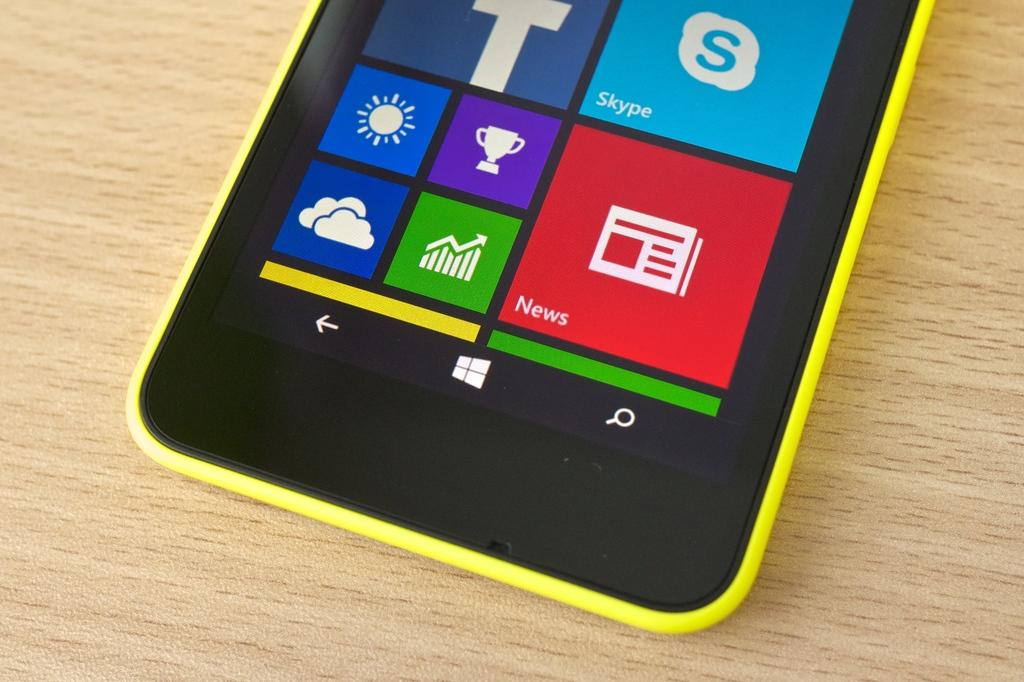<image>
Offer a succinct explanation of the picture presented. A yellow cell phone with large icons rests on a table. 